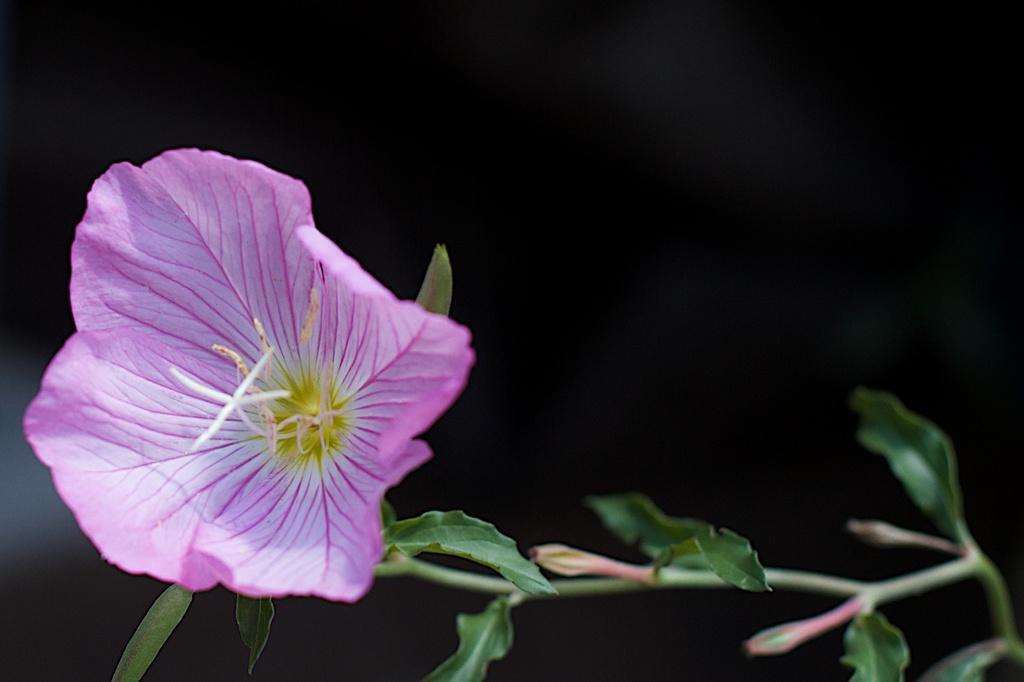In one or two sentences, can you explain what this image depicts? In this picture I can see there is a flower it is in violet. There is a stem here and there are two bugs attached to the stem and the backdrop is dark. 